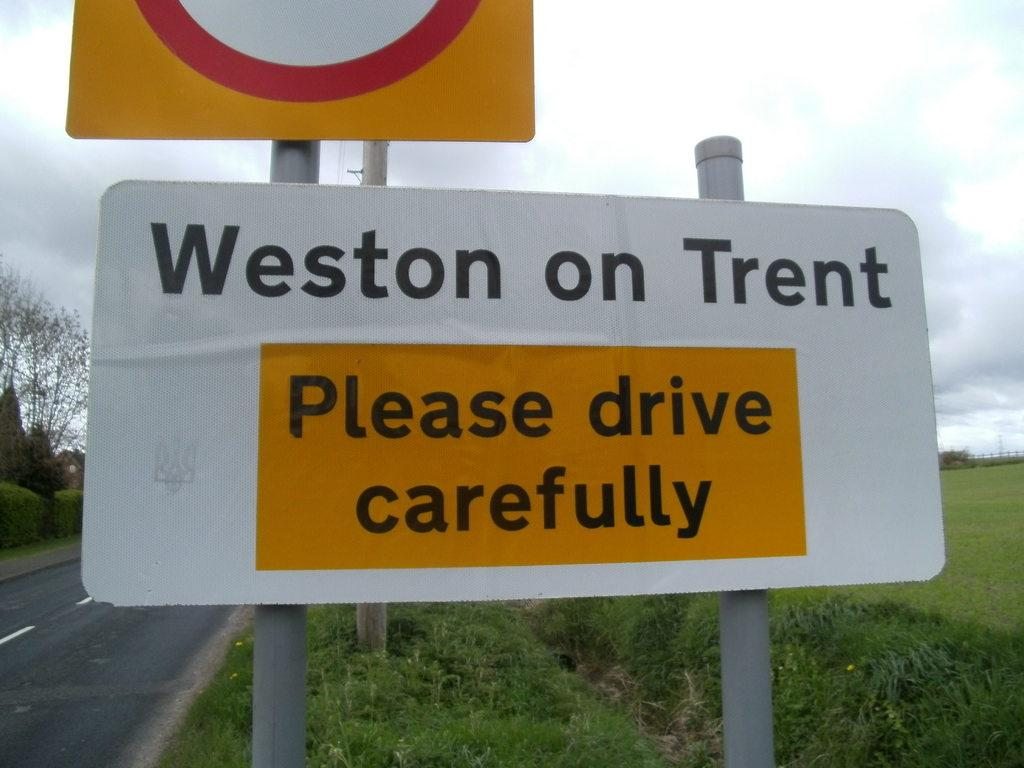<image>
Share a concise interpretation of the image provided. A sign along the road asks drivers to drive carefully. 